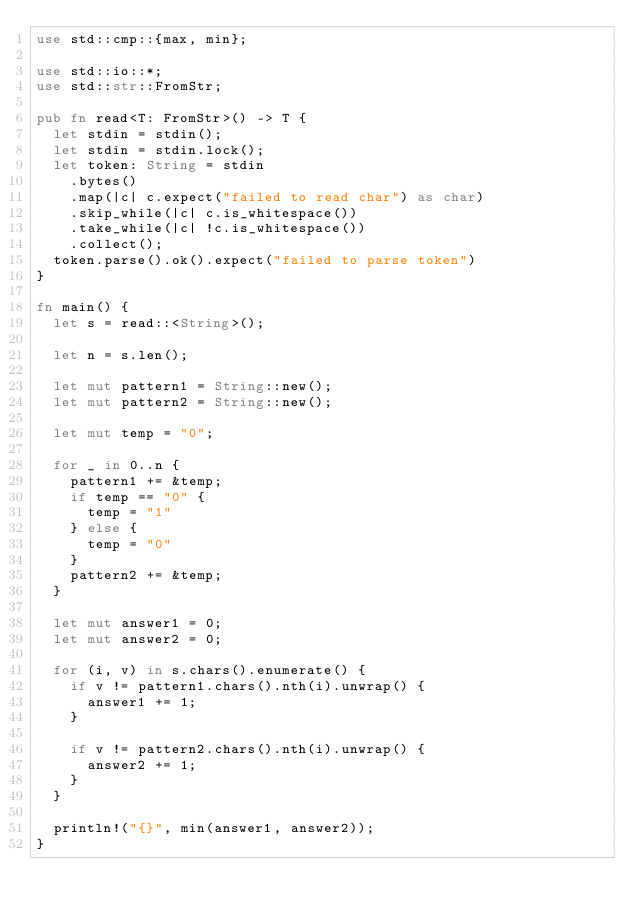<code> <loc_0><loc_0><loc_500><loc_500><_Rust_>use std::cmp::{max, min};

use std::io::*;
use std::str::FromStr;

pub fn read<T: FromStr>() -> T {
  let stdin = stdin();
  let stdin = stdin.lock();
  let token: String = stdin
    .bytes()
    .map(|c| c.expect("failed to read char") as char)
    .skip_while(|c| c.is_whitespace())
    .take_while(|c| !c.is_whitespace())
    .collect();
  token.parse().ok().expect("failed to parse token")
}

fn main() {
  let s = read::<String>();

  let n = s.len();

  let mut pattern1 = String::new();
  let mut pattern2 = String::new();

  let mut temp = "0";

  for _ in 0..n {
    pattern1 += &temp;
    if temp == "0" {
      temp = "1"
    } else {
      temp = "0"
    }
    pattern2 += &temp;
  }

  let mut answer1 = 0;
  let mut answer2 = 0;

  for (i, v) in s.chars().enumerate() {
    if v != pattern1.chars().nth(i).unwrap() {
      answer1 += 1;
    }

    if v != pattern2.chars().nth(i).unwrap() {
      answer2 += 1;
    }
  }

  println!("{}", min(answer1, answer2));
}

</code> 